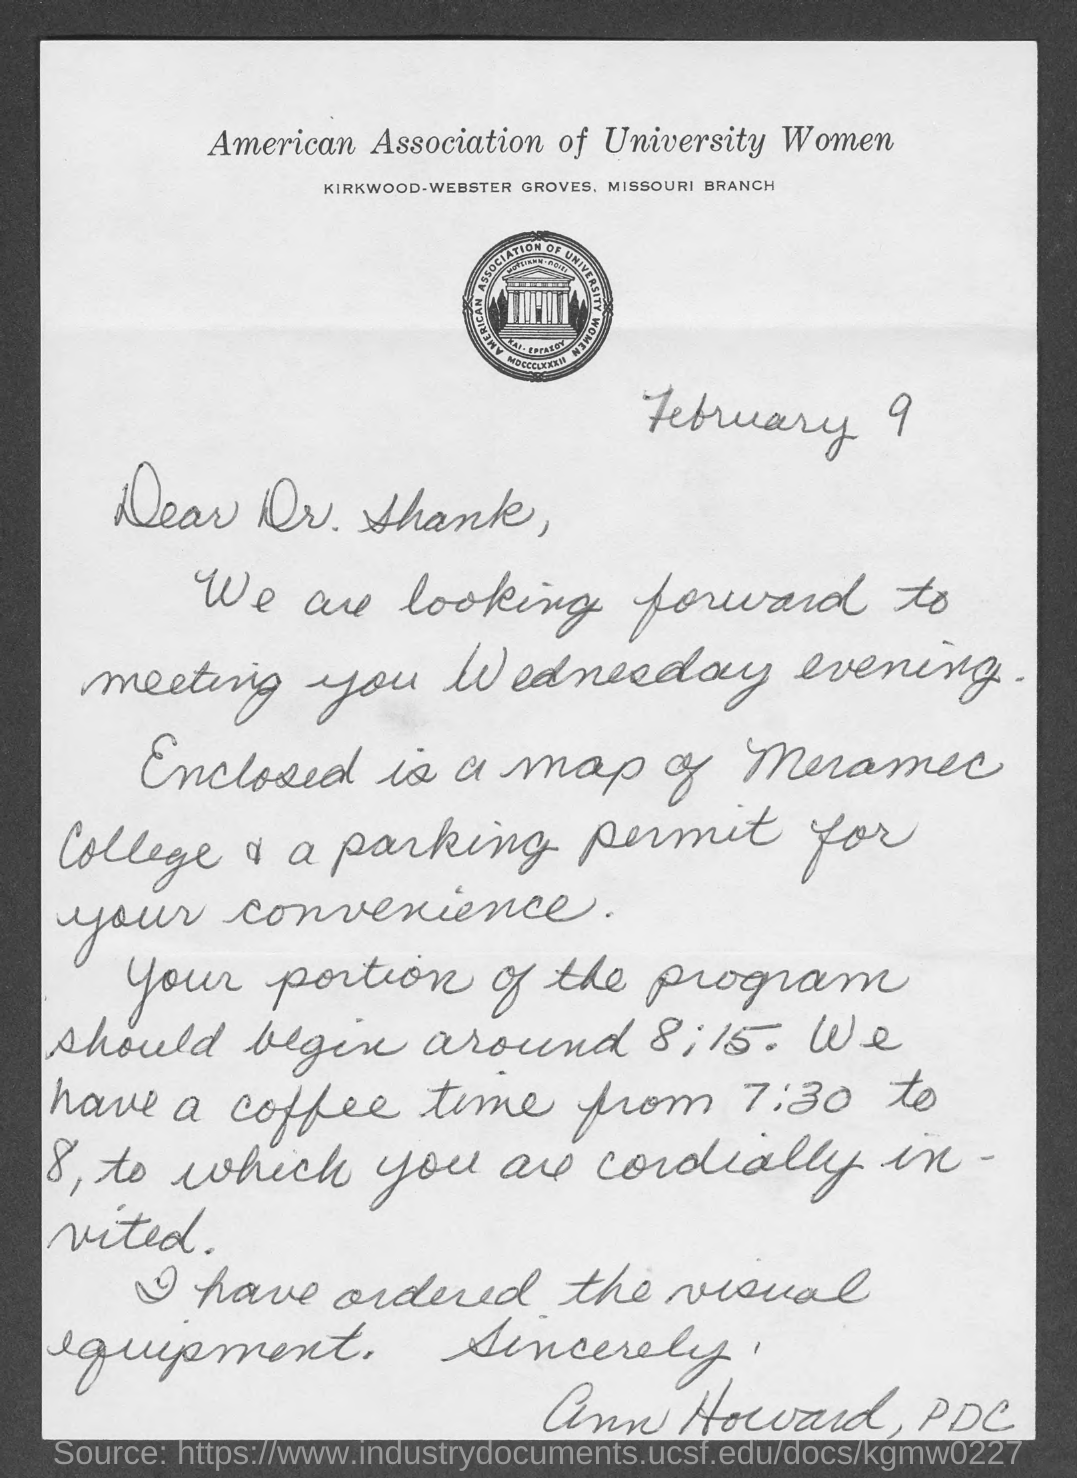Mention a couple of crucial points in this snapshot. The date mentioned in the given letter is February 9th. The American Association of University Women is the name of the association mentioned in the given page. 